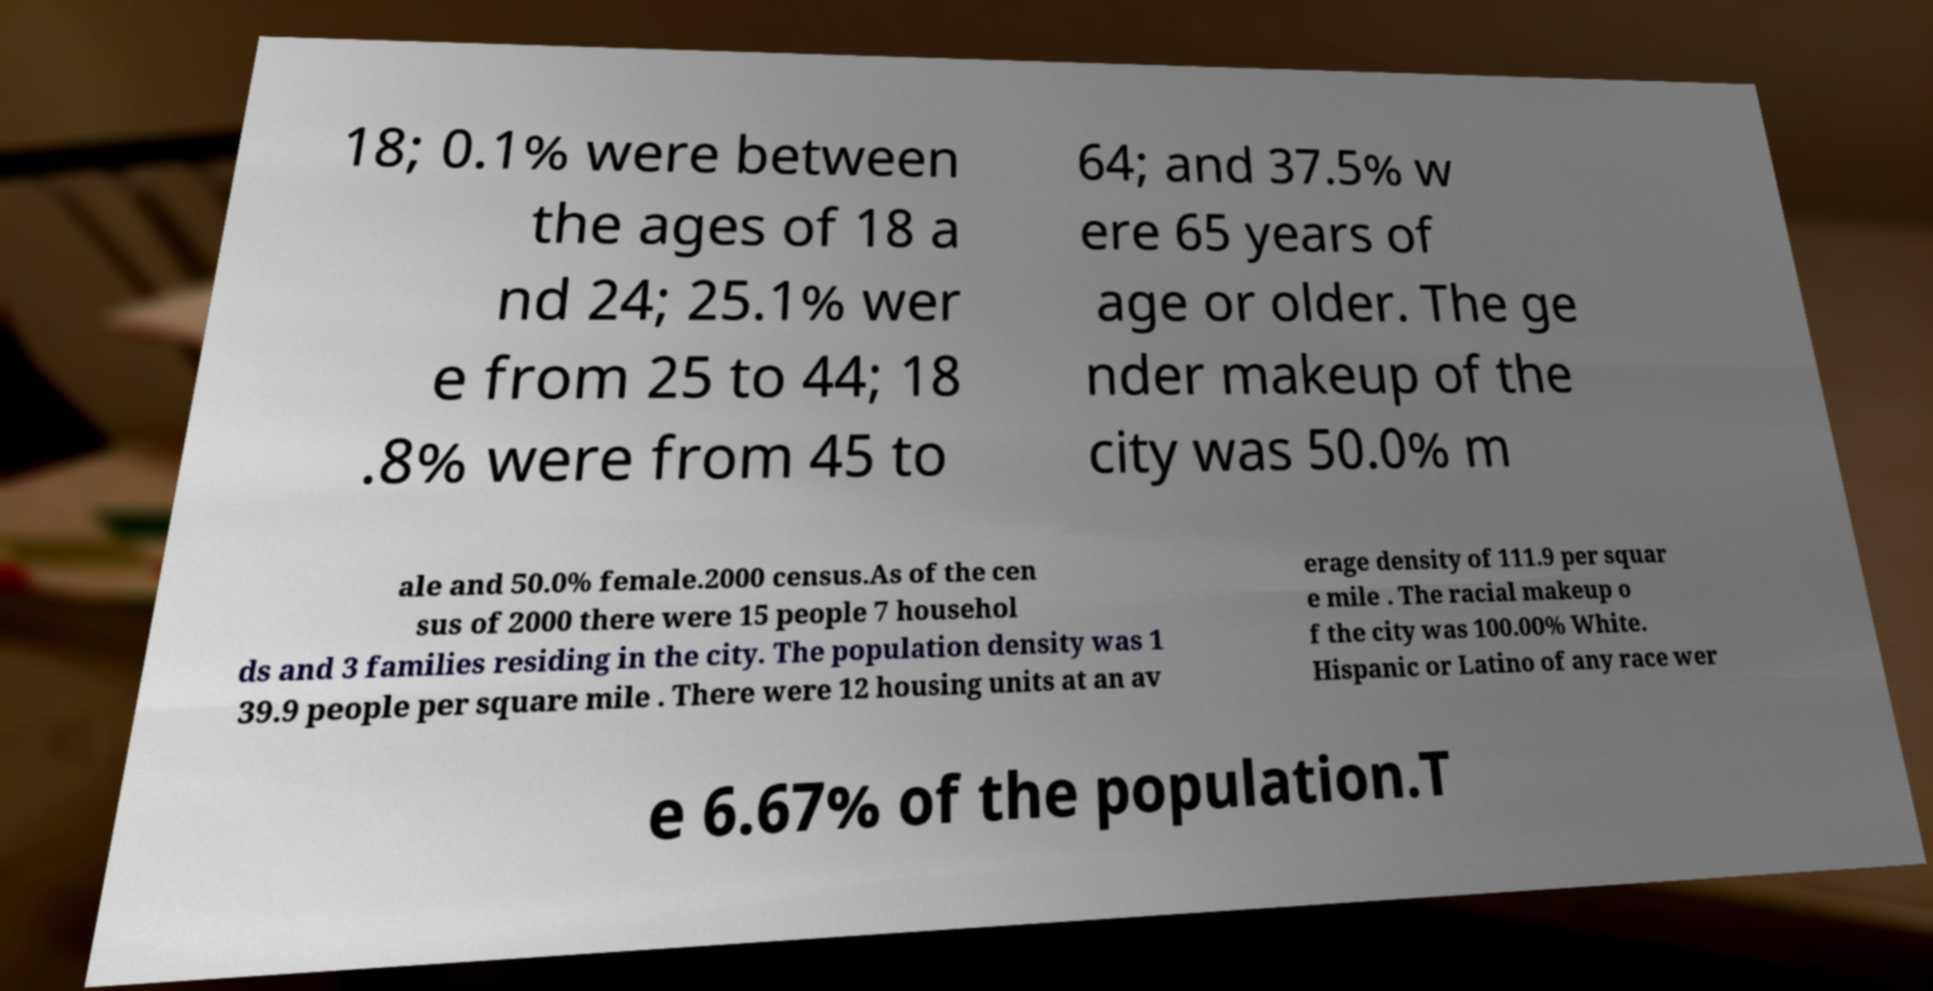Could you extract and type out the text from this image? 18; 0.1% were between the ages of 18 a nd 24; 25.1% wer e from 25 to 44; 18 .8% were from 45 to 64; and 37.5% w ere 65 years of age or older. The ge nder makeup of the city was 50.0% m ale and 50.0% female.2000 census.As of the cen sus of 2000 there were 15 people 7 househol ds and 3 families residing in the city. The population density was 1 39.9 people per square mile . There were 12 housing units at an av erage density of 111.9 per squar e mile . The racial makeup o f the city was 100.00% White. Hispanic or Latino of any race wer e 6.67% of the population.T 